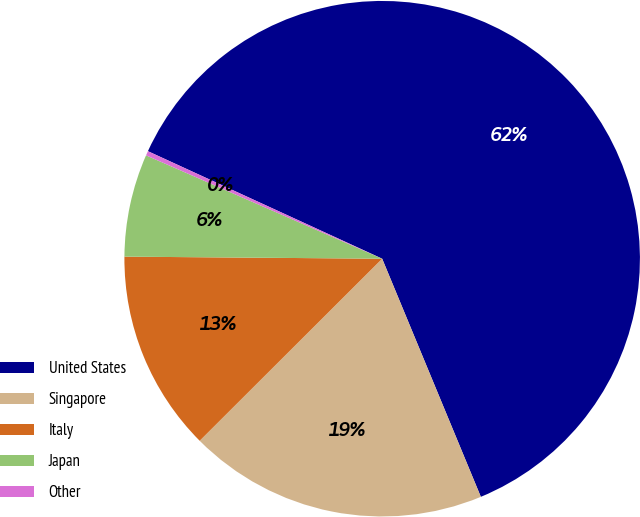Convert chart to OTSL. <chart><loc_0><loc_0><loc_500><loc_500><pie_chart><fcel>United States<fcel>Singapore<fcel>Italy<fcel>Japan<fcel>Other<nl><fcel>61.9%<fcel>18.77%<fcel>12.61%<fcel>6.44%<fcel>0.28%<nl></chart> 